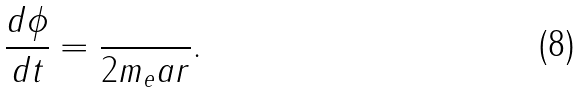<formula> <loc_0><loc_0><loc_500><loc_500>\frac { d \phi } { d t } = \frac { } { 2 m _ { e } a r } .</formula> 